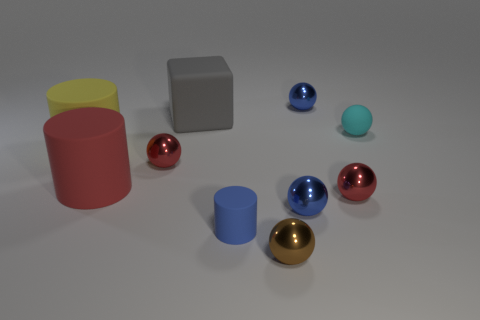Subtract all brown spheres. How many spheres are left? 5 Subtract all blue spheres. How many spheres are left? 4 Subtract all yellow spheres. Subtract all yellow blocks. How many spheres are left? 6 Subtract all cubes. How many objects are left? 9 Subtract all blue spheres. Subtract all tiny blue metal balls. How many objects are left? 6 Add 8 blue metallic objects. How many blue metallic objects are left? 10 Add 3 small red metal objects. How many small red metal objects exist? 5 Subtract 0 purple balls. How many objects are left? 10 